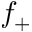<formula> <loc_0><loc_0><loc_500><loc_500>f _ { + }</formula> 